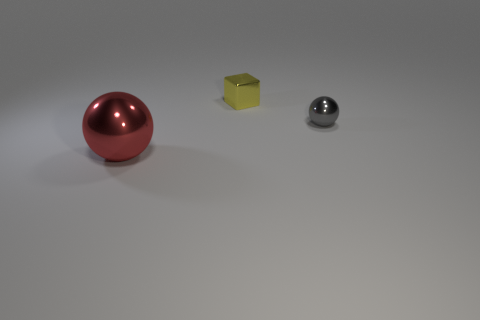What shape is the metal thing that is both on the right side of the large metal object and in front of the tiny metal cube?
Your response must be concise. Sphere. Does the shiny object that is behind the gray thing have the same size as the metal sphere to the right of the tiny shiny block?
Ensure brevity in your answer.  Yes. There is a gray object that is the same material as the large red sphere; what is its shape?
Keep it short and to the point. Sphere. Is there anything else that is the same shape as the yellow thing?
Your answer should be very brief. No. There is a shiny ball that is in front of the metal sphere that is behind the object in front of the gray thing; what is its color?
Give a very brief answer. Red. Are there fewer red shiny spheres left of the gray metal thing than shiny things in front of the yellow cube?
Offer a terse response. Yes. Does the small yellow object have the same shape as the large object?
Your answer should be compact. No. What number of gray spheres are the same size as the yellow shiny thing?
Your answer should be very brief. 1. Are there fewer tiny gray metal balls that are in front of the big shiny object than yellow metal things?
Keep it short and to the point. Yes. There is a thing that is in front of the tiny object that is in front of the yellow object; what size is it?
Make the answer very short. Large. 